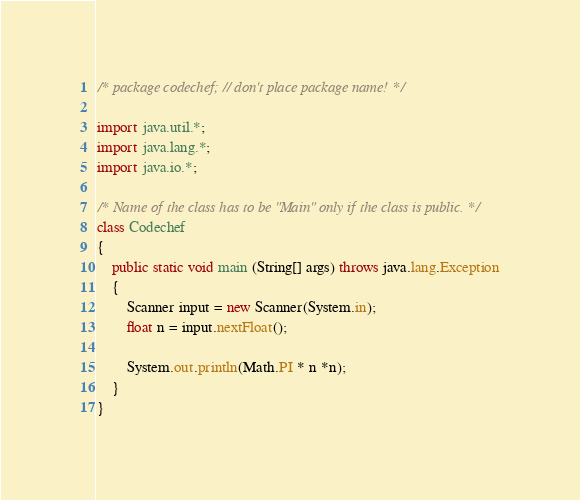Convert code to text. <code><loc_0><loc_0><loc_500><loc_500><_Java_>/* package codechef; // don't place package name! */

import java.util.*;
import java.lang.*;
import java.io.*;

/* Name of the class has to be "Main" only if the class is public. */
class Codechef
{
	public static void main (String[] args) throws java.lang.Exception
	{
		Scanner input = new Scanner(System.in);
		float n = input.nextFloat();
		 
		System.out.println(Math.PI * n *n);
	}
}
</code> 